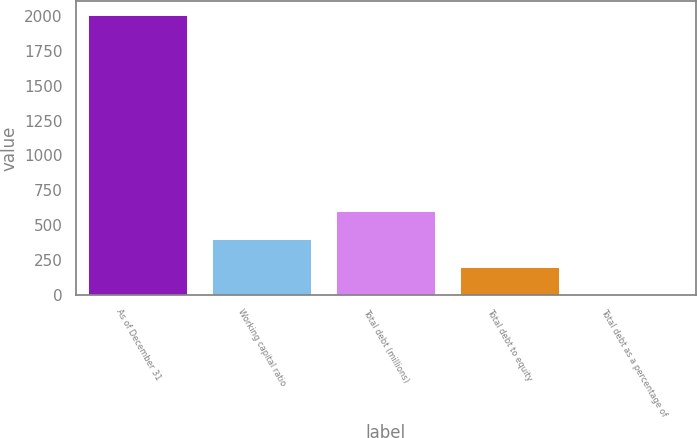<chart> <loc_0><loc_0><loc_500><loc_500><bar_chart><fcel>As of December 31<fcel>Working capital ratio<fcel>Total debt (millions)<fcel>Total debt to equity<fcel>Total debt as a percentage of<nl><fcel>2005<fcel>401.11<fcel>601.6<fcel>200.62<fcel>0.13<nl></chart> 